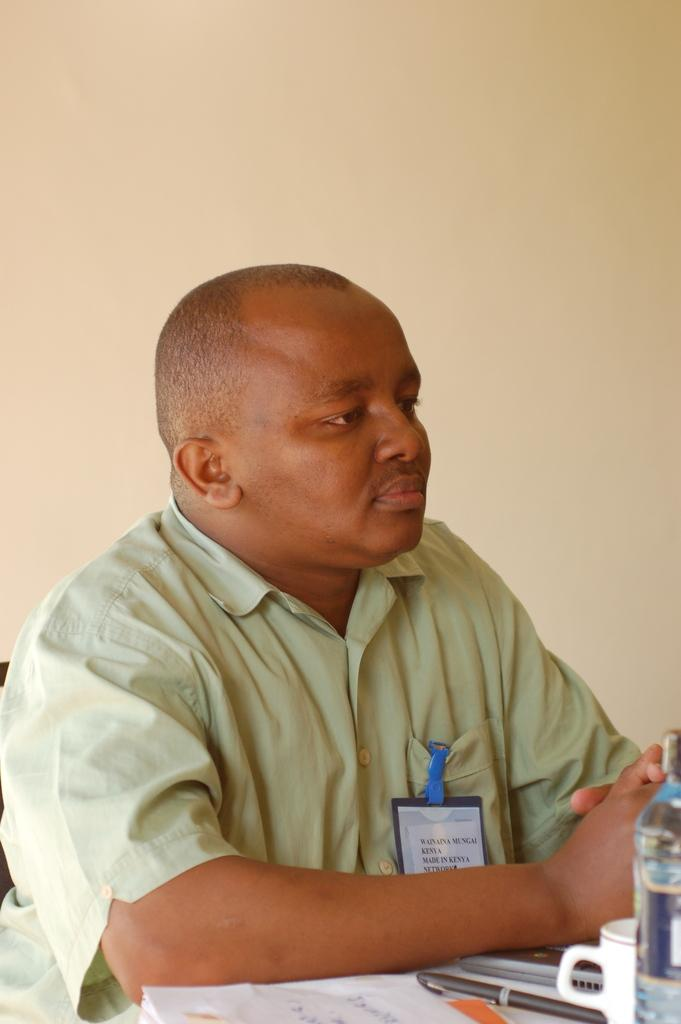What is the appearance of the man in the image? The man in the image is bald-headed. What is the man wearing in the image? The man is wearing a light green shirt. Where is the man located in the image? The man is sitting in front of a table. What objects are on the table in the image? There is a paper, a pen, a laptop, a water bottle, and a cup on the table. What is the background of the image? There is a wall behind the man. What type of shop can be seen in the background of the image? There is no shop visible in the image; the background consists of a wall. What advice does the man's mom give him in the image? There is no reference to the man's mom in the image, so it is not possible to determine what advice she might give. 